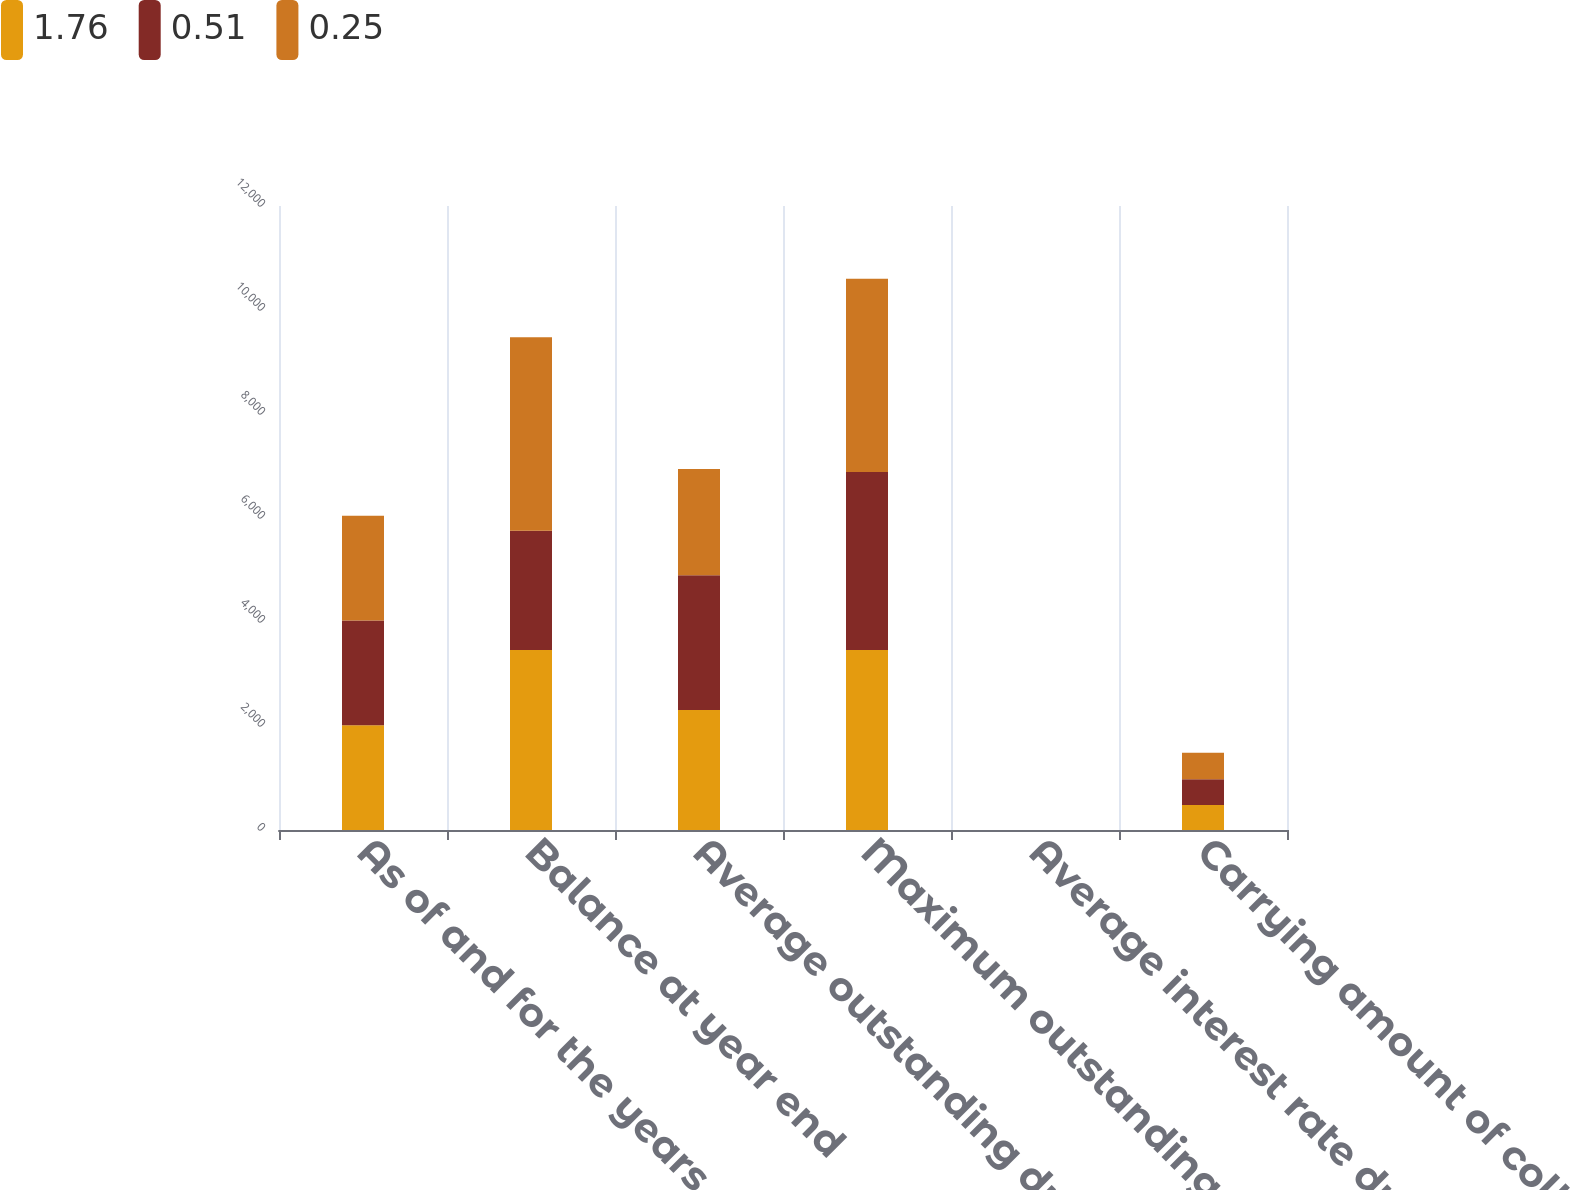Convert chart. <chart><loc_0><loc_0><loc_500><loc_500><stacked_bar_chart><ecel><fcel>As of and for the years ended<fcel>Balance at year end<fcel>Average outstanding during the<fcel>Maximum outstanding at any<fcel>Average interest rate during<fcel>Carrying amount of collateral<nl><fcel>1.76<fcel>2015<fcel>3463.8<fcel>2306.6<fcel>3463.8<fcel>0.42<fcel>478.9<nl><fcel>0.51<fcel>2014<fcel>2291.7<fcel>2593.7<fcel>3419.5<fcel>0.36<fcel>495.7<nl><fcel>0.25<fcel>2013<fcel>3719.8<fcel>2043.9<fcel>3719.8<fcel>0.4<fcel>511.2<nl></chart> 